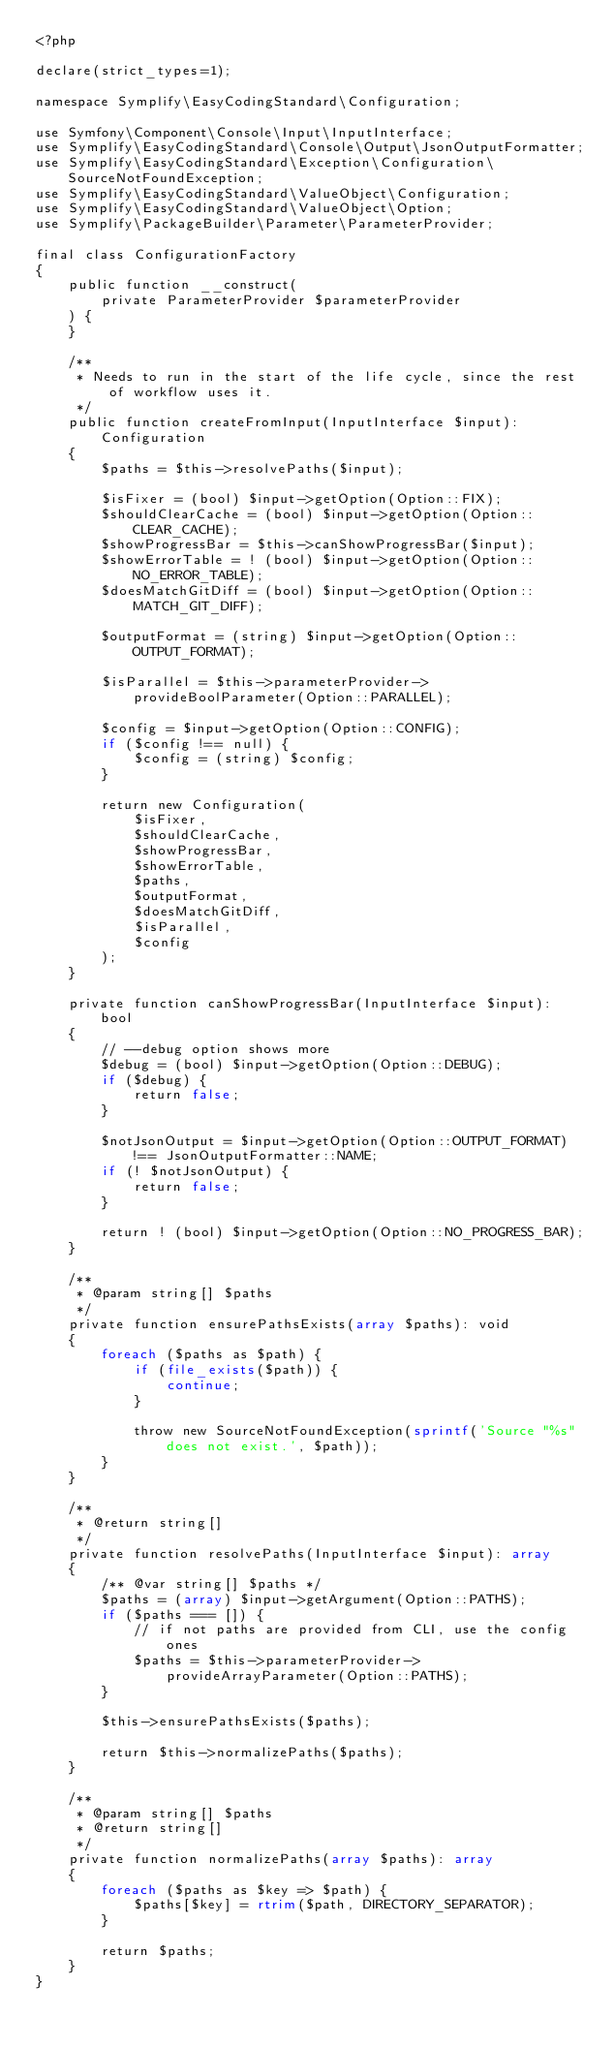<code> <loc_0><loc_0><loc_500><loc_500><_PHP_><?php

declare(strict_types=1);

namespace Symplify\EasyCodingStandard\Configuration;

use Symfony\Component\Console\Input\InputInterface;
use Symplify\EasyCodingStandard\Console\Output\JsonOutputFormatter;
use Symplify\EasyCodingStandard\Exception\Configuration\SourceNotFoundException;
use Symplify\EasyCodingStandard\ValueObject\Configuration;
use Symplify\EasyCodingStandard\ValueObject\Option;
use Symplify\PackageBuilder\Parameter\ParameterProvider;

final class ConfigurationFactory
{
    public function __construct(
        private ParameterProvider $parameterProvider
    ) {
    }

    /**
     * Needs to run in the start of the life cycle, since the rest of workflow uses it.
     */
    public function createFromInput(InputInterface $input): Configuration
    {
        $paths = $this->resolvePaths($input);

        $isFixer = (bool) $input->getOption(Option::FIX);
        $shouldClearCache = (bool) $input->getOption(Option::CLEAR_CACHE);
        $showProgressBar = $this->canShowProgressBar($input);
        $showErrorTable = ! (bool) $input->getOption(Option::NO_ERROR_TABLE);
        $doesMatchGitDiff = (bool) $input->getOption(Option::MATCH_GIT_DIFF);

        $outputFormat = (string) $input->getOption(Option::OUTPUT_FORMAT);

        $isParallel = $this->parameterProvider->provideBoolParameter(Option::PARALLEL);

        $config = $input->getOption(Option::CONFIG);
        if ($config !== null) {
            $config = (string) $config;
        }

        return new Configuration(
            $isFixer,
            $shouldClearCache,
            $showProgressBar,
            $showErrorTable,
            $paths,
            $outputFormat,
            $doesMatchGitDiff,
            $isParallel,
            $config
        );
    }

    private function canShowProgressBar(InputInterface $input): bool
    {
        // --debug option shows more
        $debug = (bool) $input->getOption(Option::DEBUG);
        if ($debug) {
            return false;
        }

        $notJsonOutput = $input->getOption(Option::OUTPUT_FORMAT) !== JsonOutputFormatter::NAME;
        if (! $notJsonOutput) {
            return false;
        }

        return ! (bool) $input->getOption(Option::NO_PROGRESS_BAR);
    }

    /**
     * @param string[] $paths
     */
    private function ensurePathsExists(array $paths): void
    {
        foreach ($paths as $path) {
            if (file_exists($path)) {
                continue;
            }

            throw new SourceNotFoundException(sprintf('Source "%s" does not exist.', $path));
        }
    }

    /**
     * @return string[]
     */
    private function resolvePaths(InputInterface $input): array
    {
        /** @var string[] $paths */
        $paths = (array) $input->getArgument(Option::PATHS);
        if ($paths === []) {
            // if not paths are provided from CLI, use the config ones
            $paths = $this->parameterProvider->provideArrayParameter(Option::PATHS);
        }

        $this->ensurePathsExists($paths);

        return $this->normalizePaths($paths);
    }

    /**
     * @param string[] $paths
     * @return string[]
     */
    private function normalizePaths(array $paths): array
    {
        foreach ($paths as $key => $path) {
            $paths[$key] = rtrim($path, DIRECTORY_SEPARATOR);
        }

        return $paths;
    }
}
</code> 